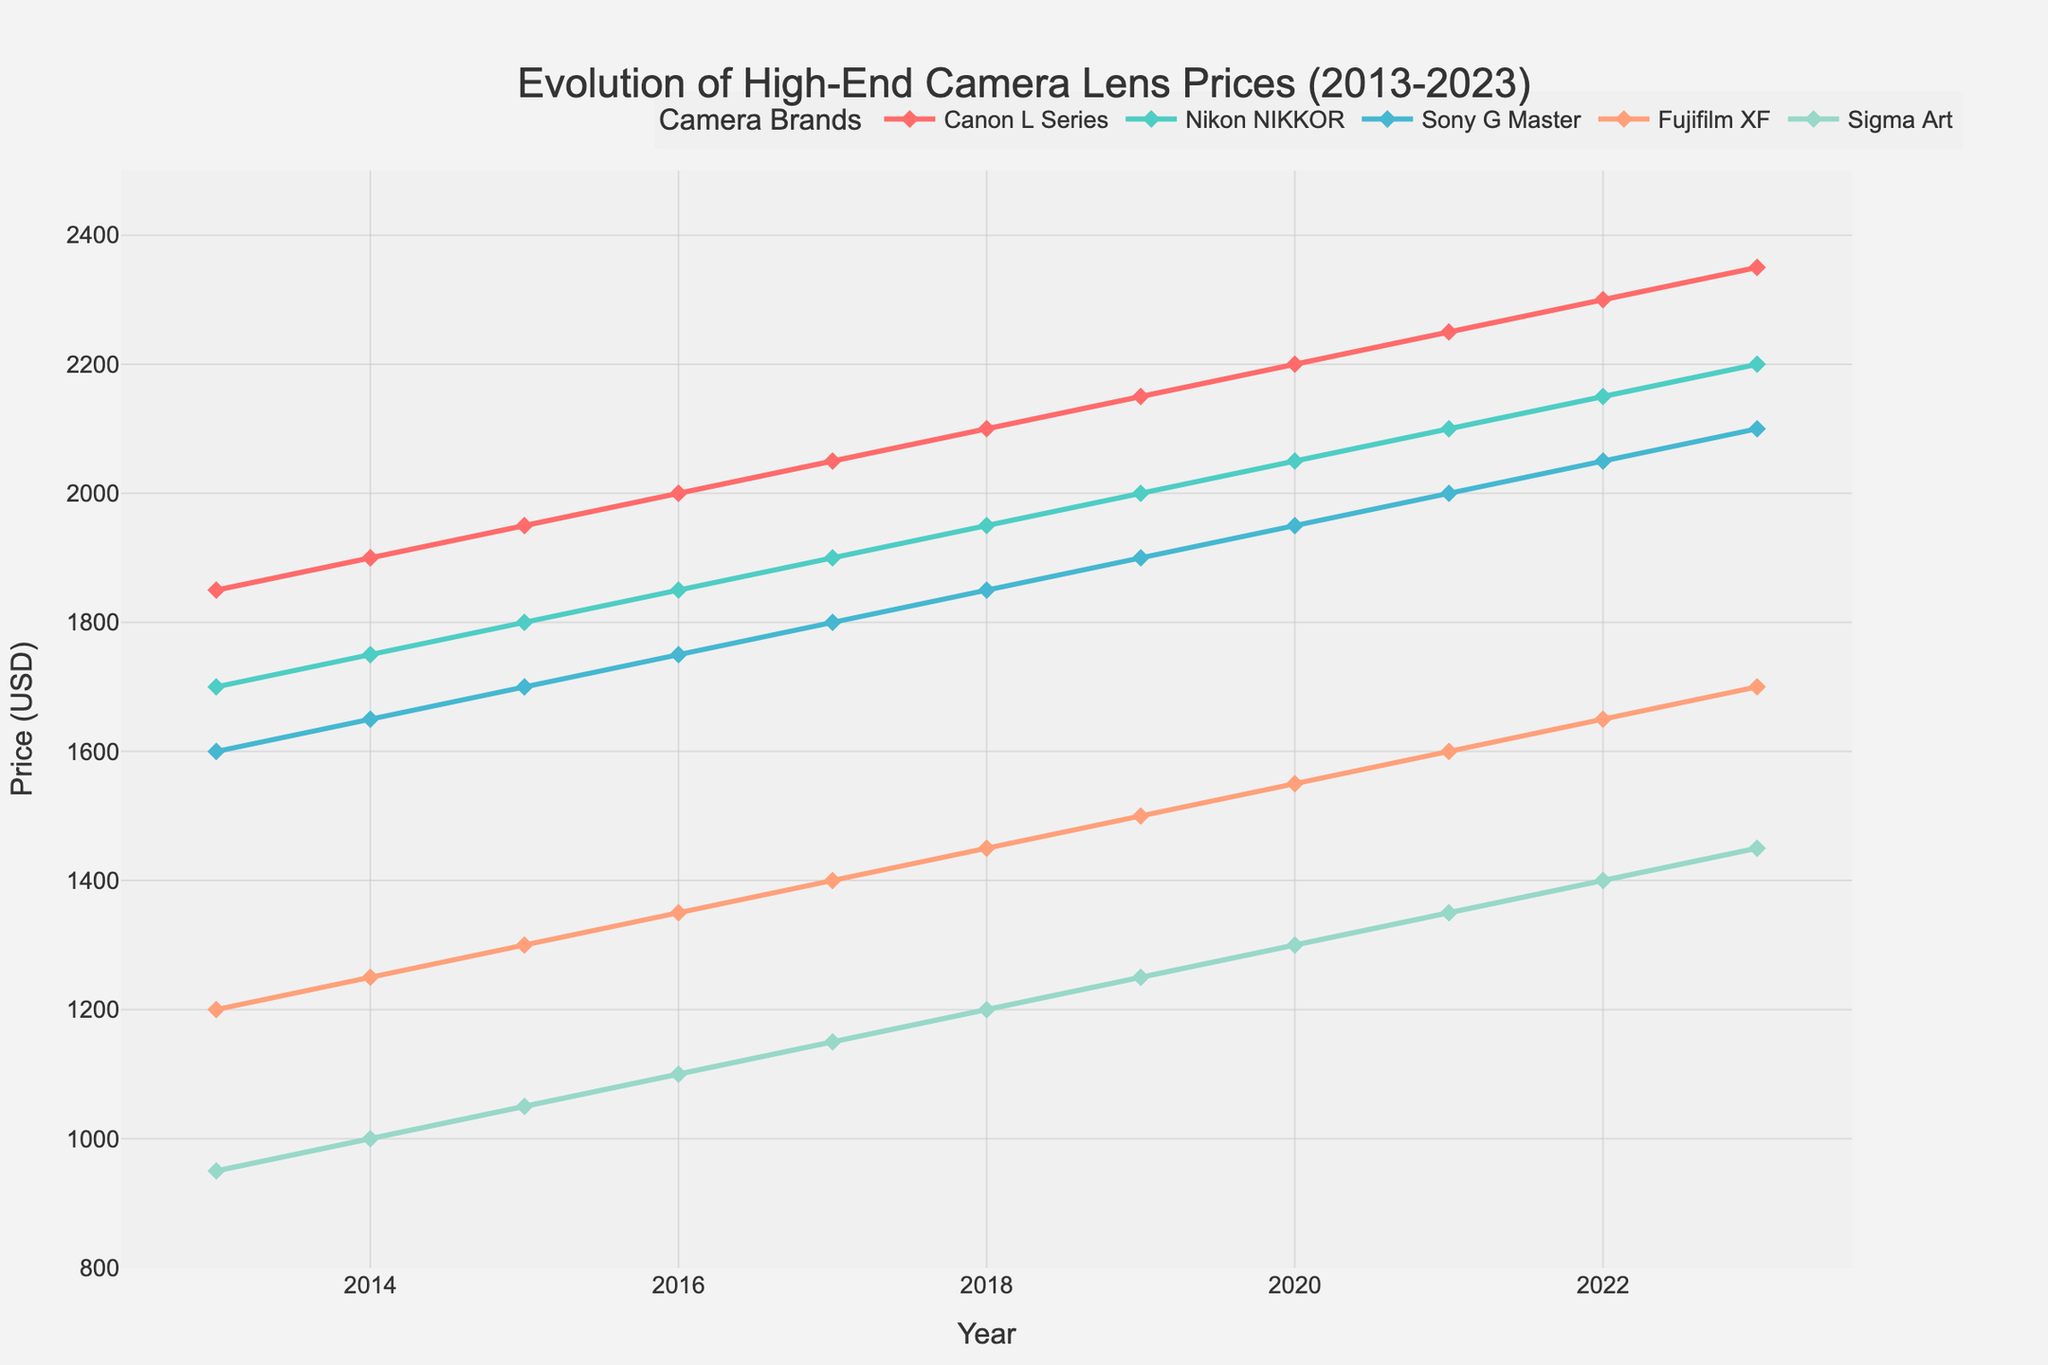Which brand had the highest price in 2023? By looking at the end of the lines for the year 2023, we can see which brand's line is at the highest position. The Canon L Series line is at the highest point of the y-axis in 2023.
Answer: Canon L Series How has the price of Fujifilm XF lenses changed from 2013 to 2023? To determine the change, we need to look at the starting point in 2013 and the endpoint in 2023 for the Fujifilm XF line. In 2013, it was $1200, and in 2023, it is $1700. The change is $1700 - $1200 = $500.
Answer: Increased by $500 Which brand exhibited the most significant price jump between any two consecutive years? By comparing the differences between consecutive years for all brands, we can identify the largest price increase. Between 2019 and 2020, Canon had a $50 increase from $2150 to $2200. Since this is the same for other years, we need to look more carefully. However, Canon consistently had the largest jumps compared to other brands.
Answer: Canon L Series What was the average price of Nikon NIKKOR lenses over the decade? To find the average, sum up the yearly prices for Nikon NIKKOR from 2013 to 2023 and then divide by the number of years. ($1700 + $1750 + $1800 + $1850 + $1900 + $1950 + $2000 + $2050 + $2100 + $2150 + $2200) / 11 = $1950
Answer: $1950 In which year did Sigma Art lenses surpass the $1000 mark? The Sigma Art line surpasses $1000 in 2015 when it is exactly $1050.
Answer: 2015 Which two brands had the closest prices in 2020? Looking at the prices for 2020, we see Canon L Series at $2200, Nikon NIKKOR at $2050, Sony G Master at $1950, Fujifilm XF at $1550, and Sigma Art at $1300. The closest prices are between Nikon NIKKOR and Sony G Master ($2050 and $1950).
Answer: Nikon NIKKOR and Sony G Master Did any brand's lens price decline over the decade? By examining each brand's trend line from 2013 to 2023, we see that all lines are increasing, indicating that none of the brands experienced a price decline.
Answer: No Which brand consistently had the lowest price throughout the decade? Among all the plotted brands, Sigma Art consistently sits at the bottom of the chart every year, indicating the lowest price.
Answer: Sigma Art How much did the price of Sony G Master lenses increase from 2017 to 2023? For Sony G Master, we take the price in 2017 ($1800) and in 2023 ($2100), and subtract the former from the latter: $2100 - $1800 = $300.
Answer: Increased by $300 How does the price trend of Fujifilm XF compare to Nikon NIKKOR? Both lines show an upward trend, but the Fujifilm XF increases more gradually compared to the steeper increase of Nikon NIKKOR.
Answer: Fujifilm XF increases more gradually 